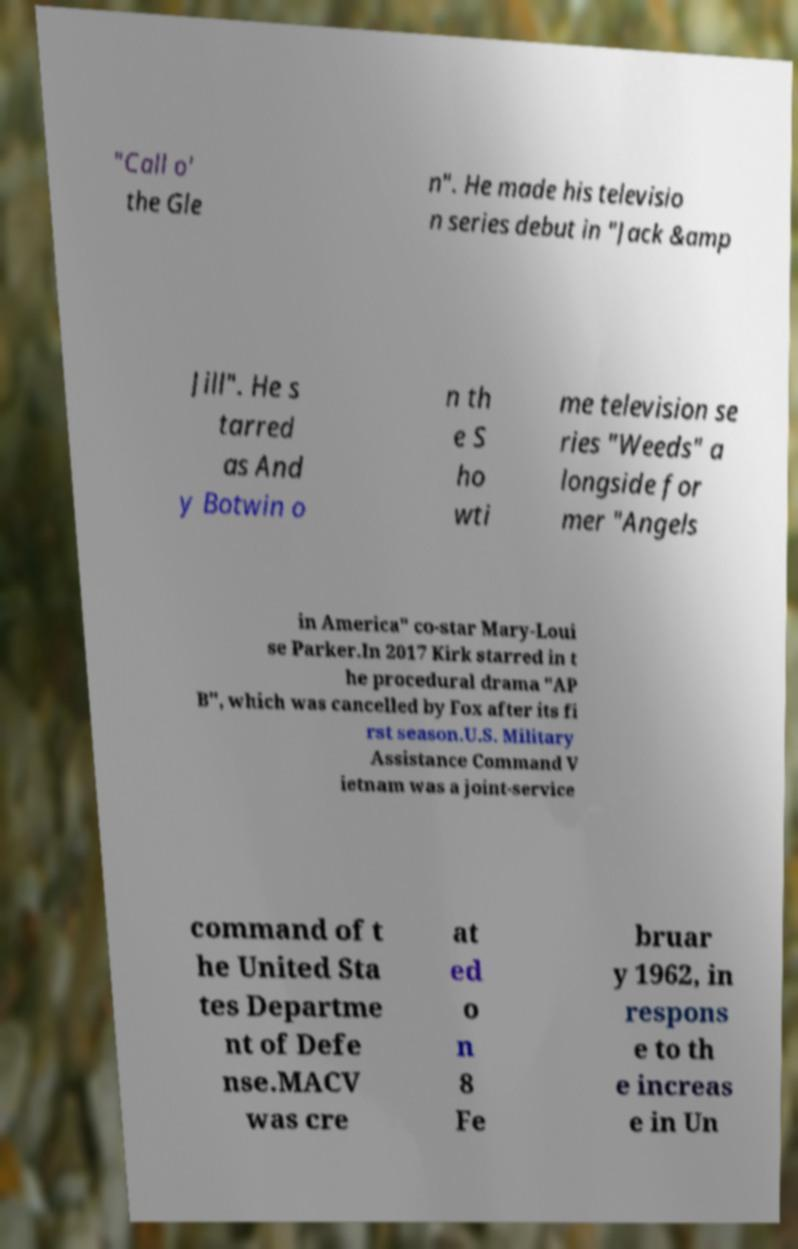I need the written content from this picture converted into text. Can you do that? "Call o' the Gle n". He made his televisio n series debut in "Jack &amp Jill". He s tarred as And y Botwin o n th e S ho wti me television se ries "Weeds" a longside for mer "Angels in America" co-star Mary-Loui se Parker.In 2017 Kirk starred in t he procedural drama "AP B", which was cancelled by Fox after its fi rst season.U.S. Military Assistance Command V ietnam was a joint-service command of t he United Sta tes Departme nt of Defe nse.MACV was cre at ed o n 8 Fe bruar y 1962, in respons e to th e increas e in Un 